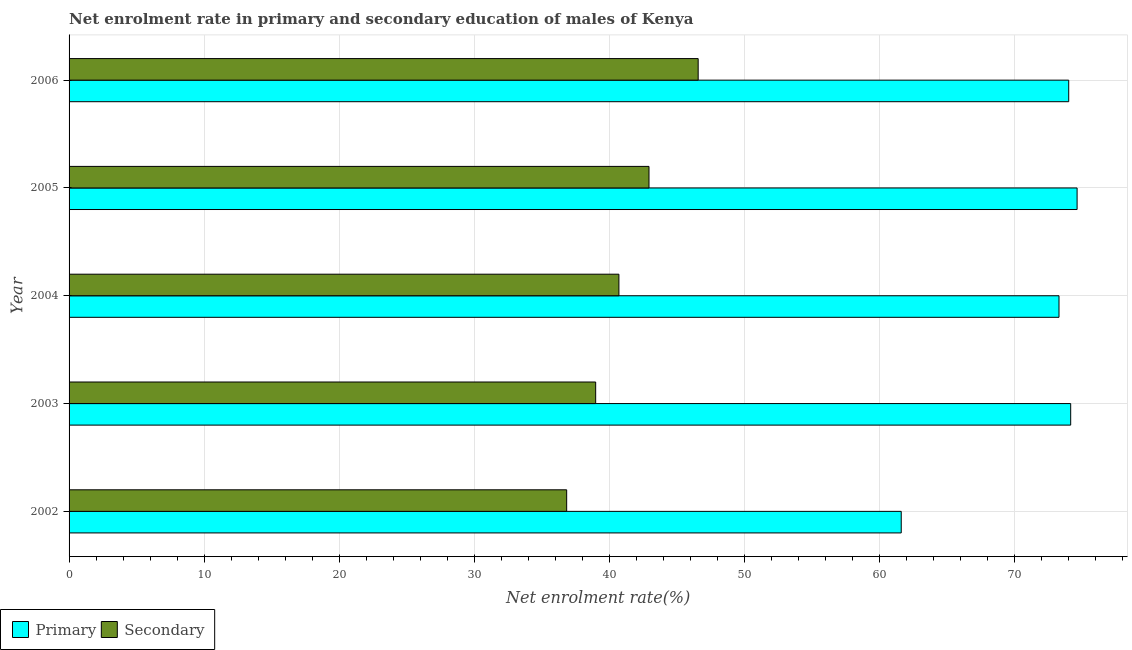How many groups of bars are there?
Make the answer very short. 5. Are the number of bars per tick equal to the number of legend labels?
Provide a succinct answer. Yes. How many bars are there on the 3rd tick from the top?
Provide a short and direct response. 2. How many bars are there on the 2nd tick from the bottom?
Ensure brevity in your answer.  2. What is the enrollment rate in secondary education in 2002?
Give a very brief answer. 36.86. Across all years, what is the maximum enrollment rate in primary education?
Keep it short and to the point. 74.67. Across all years, what is the minimum enrollment rate in secondary education?
Ensure brevity in your answer.  36.86. In which year was the enrollment rate in secondary education minimum?
Keep it short and to the point. 2002. What is the total enrollment rate in secondary education in the graph?
Make the answer very short. 206.16. What is the difference between the enrollment rate in primary education in 2002 and that in 2003?
Ensure brevity in your answer.  -12.55. What is the difference between the enrollment rate in secondary education in 2004 and the enrollment rate in primary education in 2003?
Make the answer very short. -33.47. What is the average enrollment rate in primary education per year?
Offer a very short reply. 71.58. In the year 2004, what is the difference between the enrollment rate in secondary education and enrollment rate in primary education?
Your answer should be very brief. -32.6. What is the ratio of the enrollment rate in secondary education in 2002 to that in 2005?
Provide a succinct answer. 0.86. What is the difference between the highest and the second highest enrollment rate in primary education?
Keep it short and to the point. 0.47. What is the difference between the highest and the lowest enrollment rate in primary education?
Your response must be concise. 13.03. In how many years, is the enrollment rate in secondary education greater than the average enrollment rate in secondary education taken over all years?
Your response must be concise. 2. Is the sum of the enrollment rate in primary education in 2002 and 2006 greater than the maximum enrollment rate in secondary education across all years?
Offer a very short reply. Yes. What does the 2nd bar from the top in 2002 represents?
Make the answer very short. Primary. What does the 2nd bar from the bottom in 2002 represents?
Provide a succinct answer. Secondary. Are all the bars in the graph horizontal?
Your response must be concise. Yes. What is the difference between two consecutive major ticks on the X-axis?
Provide a short and direct response. 10. Are the values on the major ticks of X-axis written in scientific E-notation?
Give a very brief answer. No. Does the graph contain any zero values?
Your answer should be very brief. No. Does the graph contain grids?
Give a very brief answer. Yes. What is the title of the graph?
Your response must be concise. Net enrolment rate in primary and secondary education of males of Kenya. What is the label or title of the X-axis?
Your answer should be very brief. Net enrolment rate(%). What is the Net enrolment rate(%) of Primary in 2002?
Offer a very short reply. 61.64. What is the Net enrolment rate(%) in Secondary in 2002?
Offer a terse response. 36.86. What is the Net enrolment rate(%) of Primary in 2003?
Give a very brief answer. 74.2. What is the Net enrolment rate(%) of Secondary in 2003?
Your response must be concise. 39.01. What is the Net enrolment rate(%) in Primary in 2004?
Offer a terse response. 73.33. What is the Net enrolment rate(%) in Secondary in 2004?
Make the answer very short. 40.73. What is the Net enrolment rate(%) of Primary in 2005?
Give a very brief answer. 74.67. What is the Net enrolment rate(%) of Secondary in 2005?
Ensure brevity in your answer.  42.96. What is the Net enrolment rate(%) in Primary in 2006?
Keep it short and to the point. 74.05. What is the Net enrolment rate(%) of Secondary in 2006?
Make the answer very short. 46.6. Across all years, what is the maximum Net enrolment rate(%) of Primary?
Give a very brief answer. 74.67. Across all years, what is the maximum Net enrolment rate(%) in Secondary?
Your answer should be compact. 46.6. Across all years, what is the minimum Net enrolment rate(%) of Primary?
Ensure brevity in your answer.  61.64. Across all years, what is the minimum Net enrolment rate(%) of Secondary?
Make the answer very short. 36.86. What is the total Net enrolment rate(%) of Primary in the graph?
Keep it short and to the point. 357.89. What is the total Net enrolment rate(%) of Secondary in the graph?
Provide a short and direct response. 206.16. What is the difference between the Net enrolment rate(%) of Primary in 2002 and that in 2003?
Offer a terse response. -12.55. What is the difference between the Net enrolment rate(%) in Secondary in 2002 and that in 2003?
Keep it short and to the point. -2.15. What is the difference between the Net enrolment rate(%) of Primary in 2002 and that in 2004?
Your answer should be very brief. -11.69. What is the difference between the Net enrolment rate(%) in Secondary in 2002 and that in 2004?
Offer a very short reply. -3.87. What is the difference between the Net enrolment rate(%) in Primary in 2002 and that in 2005?
Offer a terse response. -13.03. What is the difference between the Net enrolment rate(%) of Secondary in 2002 and that in 2005?
Give a very brief answer. -6.1. What is the difference between the Net enrolment rate(%) of Primary in 2002 and that in 2006?
Offer a terse response. -12.41. What is the difference between the Net enrolment rate(%) in Secondary in 2002 and that in 2006?
Keep it short and to the point. -9.74. What is the difference between the Net enrolment rate(%) of Primary in 2003 and that in 2004?
Offer a very short reply. 0.87. What is the difference between the Net enrolment rate(%) of Secondary in 2003 and that in 2004?
Keep it short and to the point. -1.72. What is the difference between the Net enrolment rate(%) in Primary in 2003 and that in 2005?
Your response must be concise. -0.47. What is the difference between the Net enrolment rate(%) in Secondary in 2003 and that in 2005?
Make the answer very short. -3.95. What is the difference between the Net enrolment rate(%) of Primary in 2003 and that in 2006?
Your answer should be very brief. 0.15. What is the difference between the Net enrolment rate(%) in Secondary in 2003 and that in 2006?
Your answer should be compact. -7.59. What is the difference between the Net enrolment rate(%) in Primary in 2004 and that in 2005?
Your answer should be compact. -1.34. What is the difference between the Net enrolment rate(%) in Secondary in 2004 and that in 2005?
Give a very brief answer. -2.23. What is the difference between the Net enrolment rate(%) of Primary in 2004 and that in 2006?
Make the answer very short. -0.72. What is the difference between the Net enrolment rate(%) in Secondary in 2004 and that in 2006?
Offer a very short reply. -5.87. What is the difference between the Net enrolment rate(%) of Primary in 2005 and that in 2006?
Provide a succinct answer. 0.62. What is the difference between the Net enrolment rate(%) in Secondary in 2005 and that in 2006?
Offer a terse response. -3.64. What is the difference between the Net enrolment rate(%) in Primary in 2002 and the Net enrolment rate(%) in Secondary in 2003?
Make the answer very short. 22.63. What is the difference between the Net enrolment rate(%) in Primary in 2002 and the Net enrolment rate(%) in Secondary in 2004?
Provide a short and direct response. 20.91. What is the difference between the Net enrolment rate(%) in Primary in 2002 and the Net enrolment rate(%) in Secondary in 2005?
Give a very brief answer. 18.68. What is the difference between the Net enrolment rate(%) in Primary in 2002 and the Net enrolment rate(%) in Secondary in 2006?
Provide a short and direct response. 15.04. What is the difference between the Net enrolment rate(%) of Primary in 2003 and the Net enrolment rate(%) of Secondary in 2004?
Provide a succinct answer. 33.47. What is the difference between the Net enrolment rate(%) in Primary in 2003 and the Net enrolment rate(%) in Secondary in 2005?
Give a very brief answer. 31.24. What is the difference between the Net enrolment rate(%) of Primary in 2003 and the Net enrolment rate(%) of Secondary in 2006?
Keep it short and to the point. 27.59. What is the difference between the Net enrolment rate(%) of Primary in 2004 and the Net enrolment rate(%) of Secondary in 2005?
Provide a succinct answer. 30.37. What is the difference between the Net enrolment rate(%) of Primary in 2004 and the Net enrolment rate(%) of Secondary in 2006?
Provide a succinct answer. 26.73. What is the difference between the Net enrolment rate(%) in Primary in 2005 and the Net enrolment rate(%) in Secondary in 2006?
Offer a terse response. 28.07. What is the average Net enrolment rate(%) in Primary per year?
Give a very brief answer. 71.58. What is the average Net enrolment rate(%) of Secondary per year?
Provide a short and direct response. 41.23. In the year 2002, what is the difference between the Net enrolment rate(%) of Primary and Net enrolment rate(%) of Secondary?
Offer a terse response. 24.78. In the year 2003, what is the difference between the Net enrolment rate(%) of Primary and Net enrolment rate(%) of Secondary?
Offer a very short reply. 35.19. In the year 2004, what is the difference between the Net enrolment rate(%) in Primary and Net enrolment rate(%) in Secondary?
Keep it short and to the point. 32.6. In the year 2005, what is the difference between the Net enrolment rate(%) in Primary and Net enrolment rate(%) in Secondary?
Provide a short and direct response. 31.71. In the year 2006, what is the difference between the Net enrolment rate(%) in Primary and Net enrolment rate(%) in Secondary?
Ensure brevity in your answer.  27.45. What is the ratio of the Net enrolment rate(%) in Primary in 2002 to that in 2003?
Provide a short and direct response. 0.83. What is the ratio of the Net enrolment rate(%) in Secondary in 2002 to that in 2003?
Your response must be concise. 0.94. What is the ratio of the Net enrolment rate(%) of Primary in 2002 to that in 2004?
Ensure brevity in your answer.  0.84. What is the ratio of the Net enrolment rate(%) in Secondary in 2002 to that in 2004?
Your response must be concise. 0.91. What is the ratio of the Net enrolment rate(%) of Primary in 2002 to that in 2005?
Make the answer very short. 0.83. What is the ratio of the Net enrolment rate(%) in Secondary in 2002 to that in 2005?
Ensure brevity in your answer.  0.86. What is the ratio of the Net enrolment rate(%) in Primary in 2002 to that in 2006?
Provide a succinct answer. 0.83. What is the ratio of the Net enrolment rate(%) of Secondary in 2002 to that in 2006?
Provide a succinct answer. 0.79. What is the ratio of the Net enrolment rate(%) in Primary in 2003 to that in 2004?
Provide a short and direct response. 1.01. What is the ratio of the Net enrolment rate(%) of Secondary in 2003 to that in 2004?
Offer a very short reply. 0.96. What is the ratio of the Net enrolment rate(%) in Primary in 2003 to that in 2005?
Provide a short and direct response. 0.99. What is the ratio of the Net enrolment rate(%) in Secondary in 2003 to that in 2005?
Your answer should be very brief. 0.91. What is the ratio of the Net enrolment rate(%) of Secondary in 2003 to that in 2006?
Your answer should be very brief. 0.84. What is the ratio of the Net enrolment rate(%) of Primary in 2004 to that in 2005?
Ensure brevity in your answer.  0.98. What is the ratio of the Net enrolment rate(%) in Secondary in 2004 to that in 2005?
Ensure brevity in your answer.  0.95. What is the ratio of the Net enrolment rate(%) of Primary in 2004 to that in 2006?
Provide a short and direct response. 0.99. What is the ratio of the Net enrolment rate(%) in Secondary in 2004 to that in 2006?
Ensure brevity in your answer.  0.87. What is the ratio of the Net enrolment rate(%) in Primary in 2005 to that in 2006?
Offer a terse response. 1.01. What is the ratio of the Net enrolment rate(%) of Secondary in 2005 to that in 2006?
Your answer should be very brief. 0.92. What is the difference between the highest and the second highest Net enrolment rate(%) of Primary?
Your answer should be very brief. 0.47. What is the difference between the highest and the second highest Net enrolment rate(%) in Secondary?
Give a very brief answer. 3.64. What is the difference between the highest and the lowest Net enrolment rate(%) of Primary?
Provide a short and direct response. 13.03. What is the difference between the highest and the lowest Net enrolment rate(%) of Secondary?
Your answer should be very brief. 9.74. 